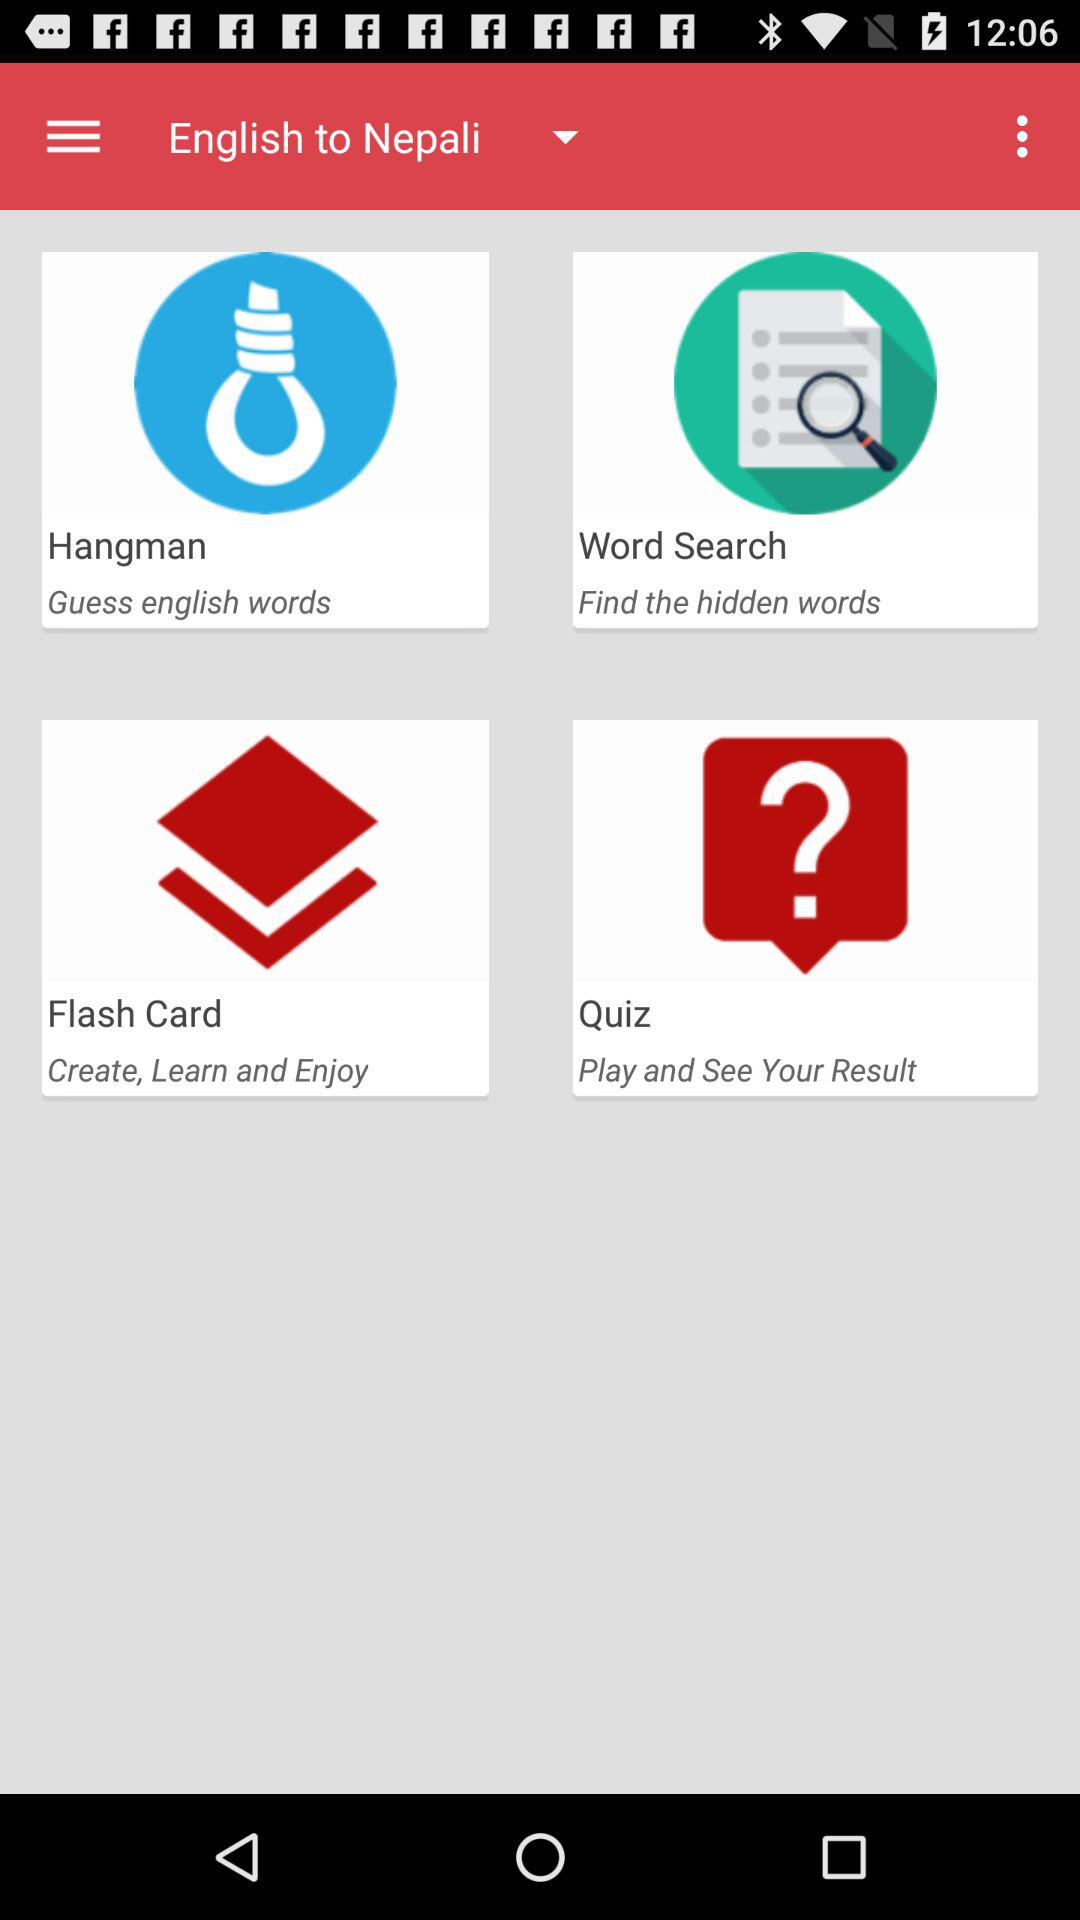What are the languages given to translate? The given languages are English and Nepali. 